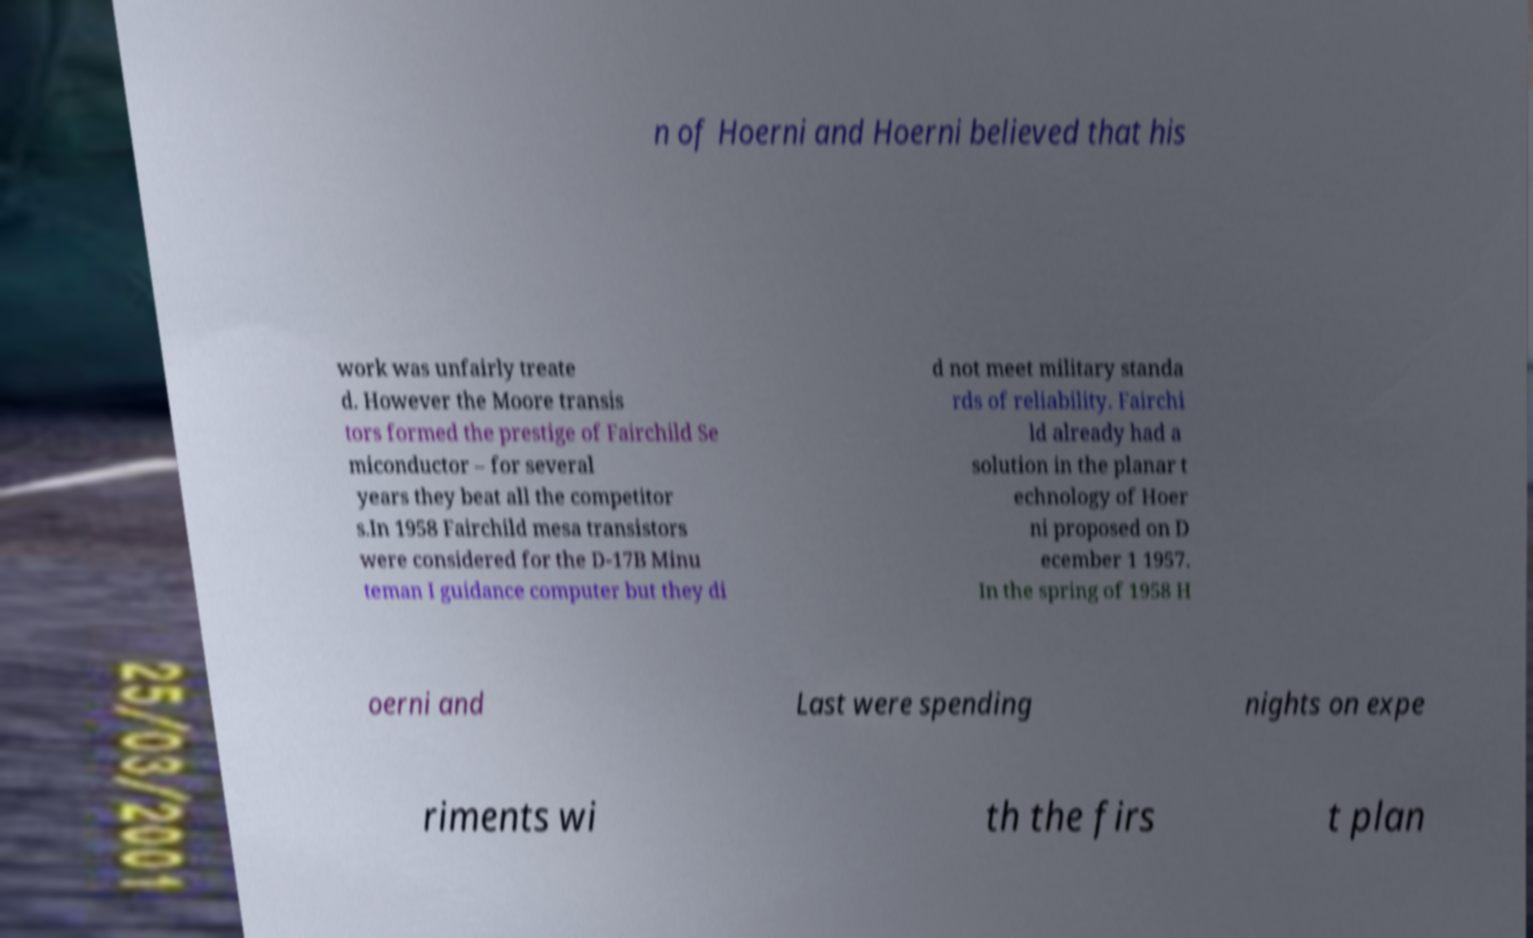Please identify and transcribe the text found in this image. n of Hoerni and Hoerni believed that his work was unfairly treate d. However the Moore transis tors formed the prestige of Fairchild Se miconductor – for several years they beat all the competitor s.In 1958 Fairchild mesa transistors were considered for the D-17B Minu teman I guidance computer but they di d not meet military standa rds of reliability. Fairchi ld already had a solution in the planar t echnology of Hoer ni proposed on D ecember 1 1957. In the spring of 1958 H oerni and Last were spending nights on expe riments wi th the firs t plan 